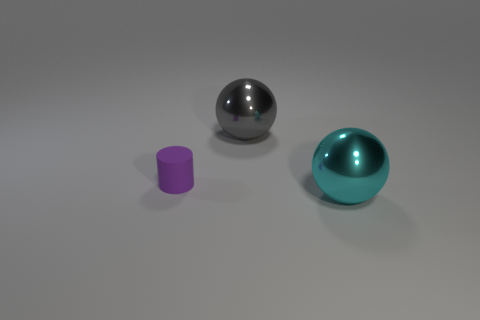Is the number of large metallic spheres on the left side of the small purple object the same as the number of large things that are in front of the gray sphere?
Your response must be concise. No. What size is the other shiny object that is the same shape as the large cyan metallic thing?
Keep it short and to the point. Large. There is a metallic object behind the purple rubber object; what shape is it?
Your answer should be very brief. Sphere. Is the large object in front of the gray metallic thing made of the same material as the thing left of the gray object?
Ensure brevity in your answer.  No. What is the shape of the gray thing?
Offer a very short reply. Sphere. Are there the same number of purple objects to the left of the small matte cylinder and cylinders?
Make the answer very short. No. Is there a small purple object made of the same material as the gray thing?
Provide a succinct answer. No. There is a object behind the purple rubber cylinder; does it have the same shape as the metal object that is in front of the gray metallic thing?
Make the answer very short. Yes. Are any small blue shiny balls visible?
Make the answer very short. No. There is another thing that is the same size as the cyan thing; what color is it?
Provide a short and direct response. Gray. 